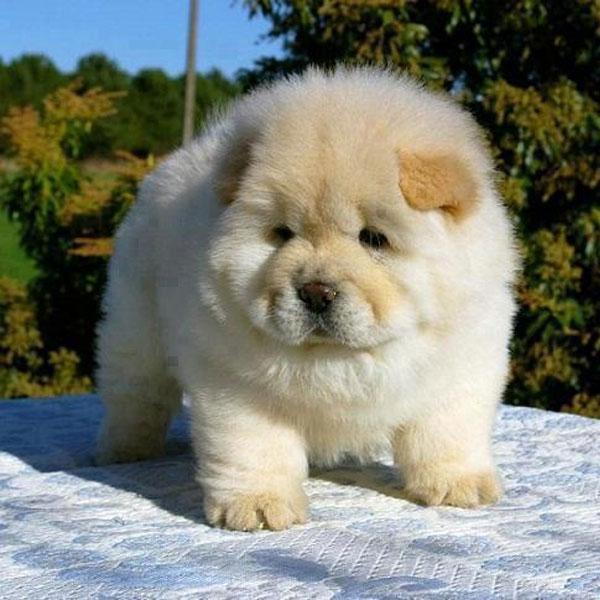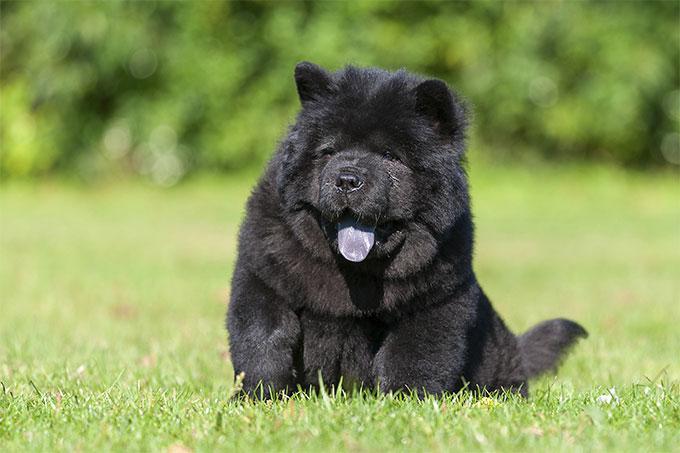The first image is the image on the left, the second image is the image on the right. For the images shown, is this caption "There is one black dog" true? Answer yes or no. Yes. 